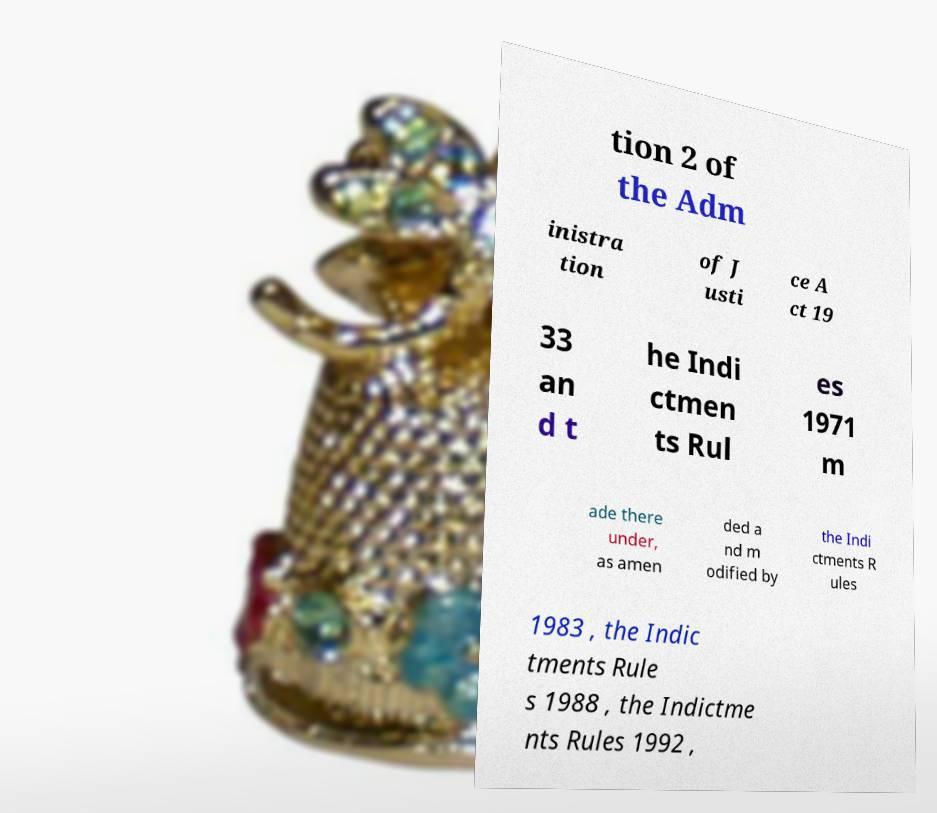Please identify and transcribe the text found in this image. tion 2 of the Adm inistra tion of J usti ce A ct 19 33 an d t he Indi ctmen ts Rul es 1971 m ade there under, as amen ded a nd m odified by the Indi ctments R ules 1983 , the Indic tments Rule s 1988 , the Indictme nts Rules 1992 , 